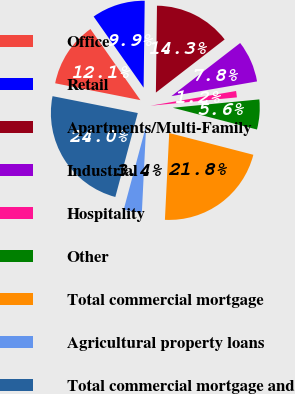<chart> <loc_0><loc_0><loc_500><loc_500><pie_chart><fcel>Office<fcel>Retail<fcel>Apartments/Multi-Family<fcel>Industrial<fcel>Hospitality<fcel>Other<fcel>Total commercial mortgage<fcel>Agricultural property loans<fcel>Total commercial mortgage and<nl><fcel>12.14%<fcel>9.95%<fcel>14.33%<fcel>7.76%<fcel>1.18%<fcel>5.56%<fcel>21.76%<fcel>3.37%<fcel>23.95%<nl></chart> 